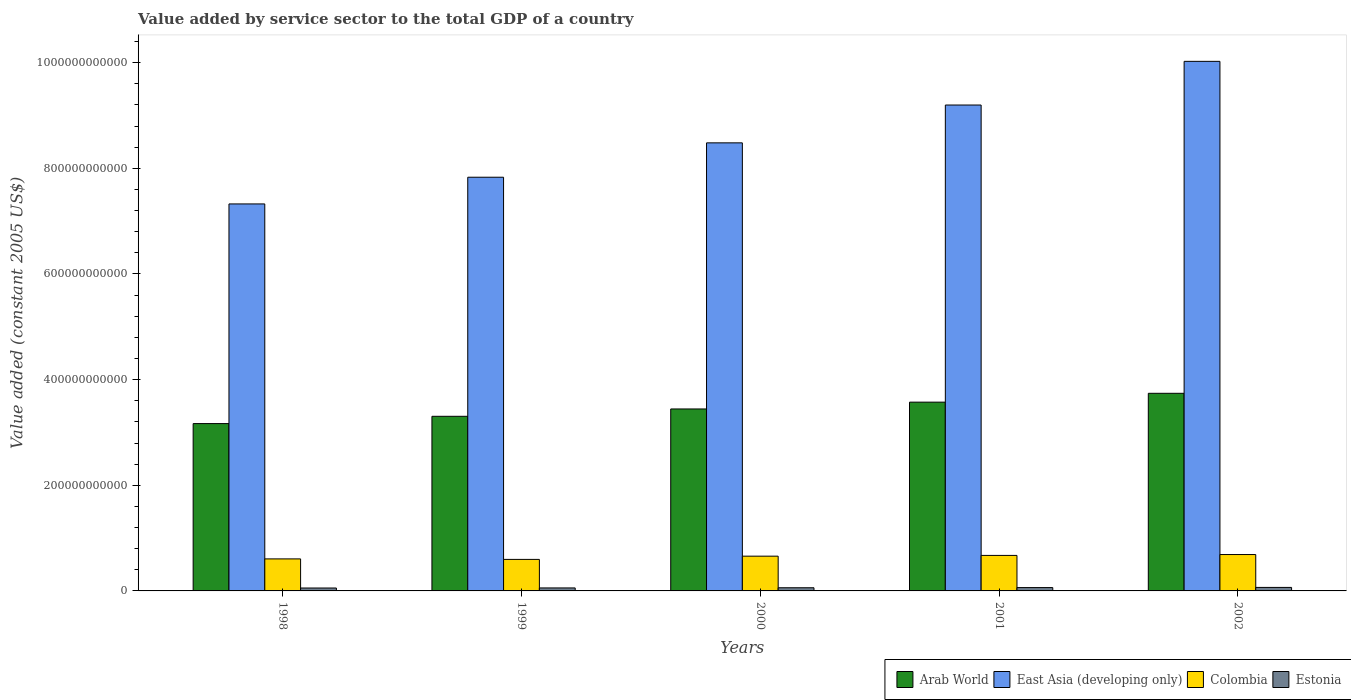Are the number of bars per tick equal to the number of legend labels?
Provide a short and direct response. Yes. Are the number of bars on each tick of the X-axis equal?
Keep it short and to the point. Yes. What is the label of the 4th group of bars from the left?
Offer a very short reply. 2001. In how many cases, is the number of bars for a given year not equal to the number of legend labels?
Your response must be concise. 0. What is the value added by service sector in Colombia in 2001?
Offer a terse response. 6.72e+1. Across all years, what is the maximum value added by service sector in Arab World?
Give a very brief answer. 3.74e+11. Across all years, what is the minimum value added by service sector in Colombia?
Your answer should be compact. 5.97e+1. What is the total value added by service sector in East Asia (developing only) in the graph?
Keep it short and to the point. 4.29e+12. What is the difference between the value added by service sector in Colombia in 1998 and that in 2000?
Offer a terse response. -5.19e+09. What is the difference between the value added by service sector in East Asia (developing only) in 2002 and the value added by service sector in Arab World in 1999?
Your answer should be very brief. 6.72e+11. What is the average value added by service sector in Arab World per year?
Your response must be concise. 3.45e+11. In the year 1998, what is the difference between the value added by service sector in East Asia (developing only) and value added by service sector in Colombia?
Your response must be concise. 6.72e+11. What is the ratio of the value added by service sector in Estonia in 1999 to that in 2002?
Ensure brevity in your answer.  0.85. Is the difference between the value added by service sector in East Asia (developing only) in 2000 and 2002 greater than the difference between the value added by service sector in Colombia in 2000 and 2002?
Your answer should be compact. No. What is the difference between the highest and the second highest value added by service sector in Colombia?
Give a very brief answer. 1.65e+09. What is the difference between the highest and the lowest value added by service sector in East Asia (developing only)?
Your response must be concise. 2.70e+11. In how many years, is the value added by service sector in East Asia (developing only) greater than the average value added by service sector in East Asia (developing only) taken over all years?
Provide a succinct answer. 2. Is the sum of the value added by service sector in East Asia (developing only) in 2001 and 2002 greater than the maximum value added by service sector in Estonia across all years?
Provide a succinct answer. Yes. What does the 4th bar from the left in 1998 represents?
Your answer should be very brief. Estonia. What does the 2nd bar from the right in 2001 represents?
Offer a very short reply. Colombia. How many bars are there?
Offer a terse response. 20. Are all the bars in the graph horizontal?
Ensure brevity in your answer.  No. What is the difference between two consecutive major ticks on the Y-axis?
Offer a terse response. 2.00e+11. Where does the legend appear in the graph?
Your answer should be compact. Bottom right. How are the legend labels stacked?
Your answer should be compact. Horizontal. What is the title of the graph?
Provide a short and direct response. Value added by service sector to the total GDP of a country. Does "Trinidad and Tobago" appear as one of the legend labels in the graph?
Your answer should be compact. No. What is the label or title of the Y-axis?
Your answer should be compact. Value added (constant 2005 US$). What is the Value added (constant 2005 US$) of Arab World in 1998?
Keep it short and to the point. 3.17e+11. What is the Value added (constant 2005 US$) in East Asia (developing only) in 1998?
Ensure brevity in your answer.  7.33e+11. What is the Value added (constant 2005 US$) in Colombia in 1998?
Keep it short and to the point. 6.06e+1. What is the Value added (constant 2005 US$) of Estonia in 1998?
Your response must be concise. 5.52e+09. What is the Value added (constant 2005 US$) in Arab World in 1999?
Give a very brief answer. 3.31e+11. What is the Value added (constant 2005 US$) of East Asia (developing only) in 1999?
Give a very brief answer. 7.83e+11. What is the Value added (constant 2005 US$) in Colombia in 1999?
Provide a short and direct response. 5.97e+1. What is the Value added (constant 2005 US$) of Estonia in 1999?
Offer a terse response. 5.65e+09. What is the Value added (constant 2005 US$) in Arab World in 2000?
Provide a short and direct response. 3.44e+11. What is the Value added (constant 2005 US$) in East Asia (developing only) in 2000?
Provide a short and direct response. 8.48e+11. What is the Value added (constant 2005 US$) in Colombia in 2000?
Provide a short and direct response. 6.58e+1. What is the Value added (constant 2005 US$) of Estonia in 2000?
Your response must be concise. 5.98e+09. What is the Value added (constant 2005 US$) in Arab World in 2001?
Provide a short and direct response. 3.57e+11. What is the Value added (constant 2005 US$) in East Asia (developing only) in 2001?
Offer a very short reply. 9.20e+11. What is the Value added (constant 2005 US$) of Colombia in 2001?
Make the answer very short. 6.72e+1. What is the Value added (constant 2005 US$) in Estonia in 2001?
Your answer should be very brief. 6.33e+09. What is the Value added (constant 2005 US$) of Arab World in 2002?
Provide a succinct answer. 3.74e+11. What is the Value added (constant 2005 US$) of East Asia (developing only) in 2002?
Give a very brief answer. 1.00e+12. What is the Value added (constant 2005 US$) of Colombia in 2002?
Offer a very short reply. 6.89e+1. What is the Value added (constant 2005 US$) of Estonia in 2002?
Your answer should be compact. 6.65e+09. Across all years, what is the maximum Value added (constant 2005 US$) of Arab World?
Offer a terse response. 3.74e+11. Across all years, what is the maximum Value added (constant 2005 US$) in East Asia (developing only)?
Make the answer very short. 1.00e+12. Across all years, what is the maximum Value added (constant 2005 US$) of Colombia?
Provide a succinct answer. 6.89e+1. Across all years, what is the maximum Value added (constant 2005 US$) of Estonia?
Provide a succinct answer. 6.65e+09. Across all years, what is the minimum Value added (constant 2005 US$) in Arab World?
Keep it short and to the point. 3.17e+11. Across all years, what is the minimum Value added (constant 2005 US$) in East Asia (developing only)?
Keep it short and to the point. 7.33e+11. Across all years, what is the minimum Value added (constant 2005 US$) in Colombia?
Ensure brevity in your answer.  5.97e+1. Across all years, what is the minimum Value added (constant 2005 US$) in Estonia?
Offer a very short reply. 5.52e+09. What is the total Value added (constant 2005 US$) of Arab World in the graph?
Provide a short and direct response. 1.72e+12. What is the total Value added (constant 2005 US$) of East Asia (developing only) in the graph?
Make the answer very short. 4.29e+12. What is the total Value added (constant 2005 US$) in Colombia in the graph?
Offer a very short reply. 3.22e+11. What is the total Value added (constant 2005 US$) of Estonia in the graph?
Keep it short and to the point. 3.01e+1. What is the difference between the Value added (constant 2005 US$) of Arab World in 1998 and that in 1999?
Your answer should be compact. -1.38e+1. What is the difference between the Value added (constant 2005 US$) of East Asia (developing only) in 1998 and that in 1999?
Provide a short and direct response. -5.06e+1. What is the difference between the Value added (constant 2005 US$) of Colombia in 1998 and that in 1999?
Offer a terse response. 9.21e+08. What is the difference between the Value added (constant 2005 US$) of Estonia in 1998 and that in 1999?
Offer a terse response. -1.28e+08. What is the difference between the Value added (constant 2005 US$) of Arab World in 1998 and that in 2000?
Make the answer very short. -2.77e+1. What is the difference between the Value added (constant 2005 US$) in East Asia (developing only) in 1998 and that in 2000?
Provide a succinct answer. -1.16e+11. What is the difference between the Value added (constant 2005 US$) in Colombia in 1998 and that in 2000?
Offer a terse response. -5.19e+09. What is the difference between the Value added (constant 2005 US$) in Estonia in 1998 and that in 2000?
Ensure brevity in your answer.  -4.53e+08. What is the difference between the Value added (constant 2005 US$) in Arab World in 1998 and that in 2001?
Provide a succinct answer. -4.06e+1. What is the difference between the Value added (constant 2005 US$) of East Asia (developing only) in 1998 and that in 2001?
Offer a very short reply. -1.87e+11. What is the difference between the Value added (constant 2005 US$) of Colombia in 1998 and that in 2001?
Your answer should be compact. -6.61e+09. What is the difference between the Value added (constant 2005 US$) in Estonia in 1998 and that in 2001?
Keep it short and to the point. -8.04e+08. What is the difference between the Value added (constant 2005 US$) in Arab World in 1998 and that in 2002?
Offer a terse response. -5.73e+1. What is the difference between the Value added (constant 2005 US$) in East Asia (developing only) in 1998 and that in 2002?
Your response must be concise. -2.70e+11. What is the difference between the Value added (constant 2005 US$) in Colombia in 1998 and that in 2002?
Ensure brevity in your answer.  -8.26e+09. What is the difference between the Value added (constant 2005 US$) in Estonia in 1998 and that in 2002?
Make the answer very short. -1.13e+09. What is the difference between the Value added (constant 2005 US$) of Arab World in 1999 and that in 2000?
Your answer should be compact. -1.39e+1. What is the difference between the Value added (constant 2005 US$) of East Asia (developing only) in 1999 and that in 2000?
Make the answer very short. -6.51e+1. What is the difference between the Value added (constant 2005 US$) in Colombia in 1999 and that in 2000?
Your response must be concise. -6.11e+09. What is the difference between the Value added (constant 2005 US$) in Estonia in 1999 and that in 2000?
Your answer should be compact. -3.25e+08. What is the difference between the Value added (constant 2005 US$) of Arab World in 1999 and that in 2001?
Provide a succinct answer. -2.68e+1. What is the difference between the Value added (constant 2005 US$) of East Asia (developing only) in 1999 and that in 2001?
Your answer should be very brief. -1.37e+11. What is the difference between the Value added (constant 2005 US$) in Colombia in 1999 and that in 2001?
Ensure brevity in your answer.  -7.53e+09. What is the difference between the Value added (constant 2005 US$) of Estonia in 1999 and that in 2001?
Give a very brief answer. -6.76e+08. What is the difference between the Value added (constant 2005 US$) in Arab World in 1999 and that in 2002?
Keep it short and to the point. -4.35e+1. What is the difference between the Value added (constant 2005 US$) in East Asia (developing only) in 1999 and that in 2002?
Provide a succinct answer. -2.19e+11. What is the difference between the Value added (constant 2005 US$) in Colombia in 1999 and that in 2002?
Give a very brief answer. -9.19e+09. What is the difference between the Value added (constant 2005 US$) in Estonia in 1999 and that in 2002?
Offer a terse response. -1.00e+09. What is the difference between the Value added (constant 2005 US$) of Arab World in 2000 and that in 2001?
Provide a succinct answer. -1.29e+1. What is the difference between the Value added (constant 2005 US$) in East Asia (developing only) in 2000 and that in 2001?
Provide a short and direct response. -7.16e+1. What is the difference between the Value added (constant 2005 US$) of Colombia in 2000 and that in 2001?
Your response must be concise. -1.42e+09. What is the difference between the Value added (constant 2005 US$) of Estonia in 2000 and that in 2001?
Give a very brief answer. -3.51e+08. What is the difference between the Value added (constant 2005 US$) of Arab World in 2000 and that in 2002?
Your answer should be very brief. -2.96e+1. What is the difference between the Value added (constant 2005 US$) in East Asia (developing only) in 2000 and that in 2002?
Keep it short and to the point. -1.54e+11. What is the difference between the Value added (constant 2005 US$) in Colombia in 2000 and that in 2002?
Your response must be concise. -3.07e+09. What is the difference between the Value added (constant 2005 US$) of Estonia in 2000 and that in 2002?
Keep it short and to the point. -6.76e+08. What is the difference between the Value added (constant 2005 US$) in Arab World in 2001 and that in 2002?
Ensure brevity in your answer.  -1.67e+1. What is the difference between the Value added (constant 2005 US$) in East Asia (developing only) in 2001 and that in 2002?
Your response must be concise. -8.27e+1. What is the difference between the Value added (constant 2005 US$) of Colombia in 2001 and that in 2002?
Make the answer very short. -1.65e+09. What is the difference between the Value added (constant 2005 US$) in Estonia in 2001 and that in 2002?
Your answer should be very brief. -3.25e+08. What is the difference between the Value added (constant 2005 US$) in Arab World in 1998 and the Value added (constant 2005 US$) in East Asia (developing only) in 1999?
Ensure brevity in your answer.  -4.66e+11. What is the difference between the Value added (constant 2005 US$) in Arab World in 1998 and the Value added (constant 2005 US$) in Colombia in 1999?
Offer a terse response. 2.57e+11. What is the difference between the Value added (constant 2005 US$) in Arab World in 1998 and the Value added (constant 2005 US$) in Estonia in 1999?
Your answer should be very brief. 3.11e+11. What is the difference between the Value added (constant 2005 US$) in East Asia (developing only) in 1998 and the Value added (constant 2005 US$) in Colombia in 1999?
Provide a succinct answer. 6.73e+11. What is the difference between the Value added (constant 2005 US$) of East Asia (developing only) in 1998 and the Value added (constant 2005 US$) of Estonia in 1999?
Your answer should be compact. 7.27e+11. What is the difference between the Value added (constant 2005 US$) in Colombia in 1998 and the Value added (constant 2005 US$) in Estonia in 1999?
Offer a very short reply. 5.50e+1. What is the difference between the Value added (constant 2005 US$) of Arab World in 1998 and the Value added (constant 2005 US$) of East Asia (developing only) in 2000?
Give a very brief answer. -5.31e+11. What is the difference between the Value added (constant 2005 US$) of Arab World in 1998 and the Value added (constant 2005 US$) of Colombia in 2000?
Ensure brevity in your answer.  2.51e+11. What is the difference between the Value added (constant 2005 US$) in Arab World in 1998 and the Value added (constant 2005 US$) in Estonia in 2000?
Your answer should be very brief. 3.11e+11. What is the difference between the Value added (constant 2005 US$) of East Asia (developing only) in 1998 and the Value added (constant 2005 US$) of Colombia in 2000?
Your answer should be very brief. 6.67e+11. What is the difference between the Value added (constant 2005 US$) of East Asia (developing only) in 1998 and the Value added (constant 2005 US$) of Estonia in 2000?
Offer a very short reply. 7.27e+11. What is the difference between the Value added (constant 2005 US$) of Colombia in 1998 and the Value added (constant 2005 US$) of Estonia in 2000?
Give a very brief answer. 5.46e+1. What is the difference between the Value added (constant 2005 US$) in Arab World in 1998 and the Value added (constant 2005 US$) in East Asia (developing only) in 2001?
Your answer should be very brief. -6.03e+11. What is the difference between the Value added (constant 2005 US$) of Arab World in 1998 and the Value added (constant 2005 US$) of Colombia in 2001?
Your response must be concise. 2.50e+11. What is the difference between the Value added (constant 2005 US$) of Arab World in 1998 and the Value added (constant 2005 US$) of Estonia in 2001?
Your answer should be compact. 3.10e+11. What is the difference between the Value added (constant 2005 US$) in East Asia (developing only) in 1998 and the Value added (constant 2005 US$) in Colombia in 2001?
Your response must be concise. 6.65e+11. What is the difference between the Value added (constant 2005 US$) of East Asia (developing only) in 1998 and the Value added (constant 2005 US$) of Estonia in 2001?
Make the answer very short. 7.26e+11. What is the difference between the Value added (constant 2005 US$) in Colombia in 1998 and the Value added (constant 2005 US$) in Estonia in 2001?
Your response must be concise. 5.43e+1. What is the difference between the Value added (constant 2005 US$) of Arab World in 1998 and the Value added (constant 2005 US$) of East Asia (developing only) in 2002?
Offer a very short reply. -6.86e+11. What is the difference between the Value added (constant 2005 US$) of Arab World in 1998 and the Value added (constant 2005 US$) of Colombia in 2002?
Offer a very short reply. 2.48e+11. What is the difference between the Value added (constant 2005 US$) of Arab World in 1998 and the Value added (constant 2005 US$) of Estonia in 2002?
Give a very brief answer. 3.10e+11. What is the difference between the Value added (constant 2005 US$) in East Asia (developing only) in 1998 and the Value added (constant 2005 US$) in Colombia in 2002?
Your answer should be very brief. 6.64e+11. What is the difference between the Value added (constant 2005 US$) in East Asia (developing only) in 1998 and the Value added (constant 2005 US$) in Estonia in 2002?
Offer a very short reply. 7.26e+11. What is the difference between the Value added (constant 2005 US$) in Colombia in 1998 and the Value added (constant 2005 US$) in Estonia in 2002?
Give a very brief answer. 5.40e+1. What is the difference between the Value added (constant 2005 US$) in Arab World in 1999 and the Value added (constant 2005 US$) in East Asia (developing only) in 2000?
Ensure brevity in your answer.  -5.18e+11. What is the difference between the Value added (constant 2005 US$) in Arab World in 1999 and the Value added (constant 2005 US$) in Colombia in 2000?
Provide a succinct answer. 2.65e+11. What is the difference between the Value added (constant 2005 US$) of Arab World in 1999 and the Value added (constant 2005 US$) of Estonia in 2000?
Ensure brevity in your answer.  3.25e+11. What is the difference between the Value added (constant 2005 US$) of East Asia (developing only) in 1999 and the Value added (constant 2005 US$) of Colombia in 2000?
Your response must be concise. 7.17e+11. What is the difference between the Value added (constant 2005 US$) of East Asia (developing only) in 1999 and the Value added (constant 2005 US$) of Estonia in 2000?
Provide a succinct answer. 7.77e+11. What is the difference between the Value added (constant 2005 US$) in Colombia in 1999 and the Value added (constant 2005 US$) in Estonia in 2000?
Provide a short and direct response. 5.37e+1. What is the difference between the Value added (constant 2005 US$) of Arab World in 1999 and the Value added (constant 2005 US$) of East Asia (developing only) in 2001?
Ensure brevity in your answer.  -5.89e+11. What is the difference between the Value added (constant 2005 US$) in Arab World in 1999 and the Value added (constant 2005 US$) in Colombia in 2001?
Keep it short and to the point. 2.63e+11. What is the difference between the Value added (constant 2005 US$) of Arab World in 1999 and the Value added (constant 2005 US$) of Estonia in 2001?
Your answer should be compact. 3.24e+11. What is the difference between the Value added (constant 2005 US$) in East Asia (developing only) in 1999 and the Value added (constant 2005 US$) in Colombia in 2001?
Offer a very short reply. 7.16e+11. What is the difference between the Value added (constant 2005 US$) of East Asia (developing only) in 1999 and the Value added (constant 2005 US$) of Estonia in 2001?
Keep it short and to the point. 7.77e+11. What is the difference between the Value added (constant 2005 US$) in Colombia in 1999 and the Value added (constant 2005 US$) in Estonia in 2001?
Provide a short and direct response. 5.34e+1. What is the difference between the Value added (constant 2005 US$) in Arab World in 1999 and the Value added (constant 2005 US$) in East Asia (developing only) in 2002?
Make the answer very short. -6.72e+11. What is the difference between the Value added (constant 2005 US$) in Arab World in 1999 and the Value added (constant 2005 US$) in Colombia in 2002?
Your response must be concise. 2.62e+11. What is the difference between the Value added (constant 2005 US$) of Arab World in 1999 and the Value added (constant 2005 US$) of Estonia in 2002?
Give a very brief answer. 3.24e+11. What is the difference between the Value added (constant 2005 US$) of East Asia (developing only) in 1999 and the Value added (constant 2005 US$) of Colombia in 2002?
Provide a succinct answer. 7.14e+11. What is the difference between the Value added (constant 2005 US$) in East Asia (developing only) in 1999 and the Value added (constant 2005 US$) in Estonia in 2002?
Ensure brevity in your answer.  7.76e+11. What is the difference between the Value added (constant 2005 US$) of Colombia in 1999 and the Value added (constant 2005 US$) of Estonia in 2002?
Offer a terse response. 5.30e+1. What is the difference between the Value added (constant 2005 US$) of Arab World in 2000 and the Value added (constant 2005 US$) of East Asia (developing only) in 2001?
Offer a very short reply. -5.75e+11. What is the difference between the Value added (constant 2005 US$) in Arab World in 2000 and the Value added (constant 2005 US$) in Colombia in 2001?
Ensure brevity in your answer.  2.77e+11. What is the difference between the Value added (constant 2005 US$) in Arab World in 2000 and the Value added (constant 2005 US$) in Estonia in 2001?
Make the answer very short. 3.38e+11. What is the difference between the Value added (constant 2005 US$) of East Asia (developing only) in 2000 and the Value added (constant 2005 US$) of Colombia in 2001?
Provide a short and direct response. 7.81e+11. What is the difference between the Value added (constant 2005 US$) in East Asia (developing only) in 2000 and the Value added (constant 2005 US$) in Estonia in 2001?
Your answer should be compact. 8.42e+11. What is the difference between the Value added (constant 2005 US$) of Colombia in 2000 and the Value added (constant 2005 US$) of Estonia in 2001?
Provide a succinct answer. 5.95e+1. What is the difference between the Value added (constant 2005 US$) in Arab World in 2000 and the Value added (constant 2005 US$) in East Asia (developing only) in 2002?
Your response must be concise. -6.58e+11. What is the difference between the Value added (constant 2005 US$) in Arab World in 2000 and the Value added (constant 2005 US$) in Colombia in 2002?
Offer a very short reply. 2.76e+11. What is the difference between the Value added (constant 2005 US$) in Arab World in 2000 and the Value added (constant 2005 US$) in Estonia in 2002?
Your answer should be compact. 3.38e+11. What is the difference between the Value added (constant 2005 US$) of East Asia (developing only) in 2000 and the Value added (constant 2005 US$) of Colombia in 2002?
Your response must be concise. 7.79e+11. What is the difference between the Value added (constant 2005 US$) of East Asia (developing only) in 2000 and the Value added (constant 2005 US$) of Estonia in 2002?
Your answer should be compact. 8.42e+11. What is the difference between the Value added (constant 2005 US$) of Colombia in 2000 and the Value added (constant 2005 US$) of Estonia in 2002?
Ensure brevity in your answer.  5.91e+1. What is the difference between the Value added (constant 2005 US$) of Arab World in 2001 and the Value added (constant 2005 US$) of East Asia (developing only) in 2002?
Make the answer very short. -6.45e+11. What is the difference between the Value added (constant 2005 US$) of Arab World in 2001 and the Value added (constant 2005 US$) of Colombia in 2002?
Your response must be concise. 2.88e+11. What is the difference between the Value added (constant 2005 US$) in Arab World in 2001 and the Value added (constant 2005 US$) in Estonia in 2002?
Ensure brevity in your answer.  3.51e+11. What is the difference between the Value added (constant 2005 US$) in East Asia (developing only) in 2001 and the Value added (constant 2005 US$) in Colombia in 2002?
Give a very brief answer. 8.51e+11. What is the difference between the Value added (constant 2005 US$) in East Asia (developing only) in 2001 and the Value added (constant 2005 US$) in Estonia in 2002?
Your response must be concise. 9.13e+11. What is the difference between the Value added (constant 2005 US$) of Colombia in 2001 and the Value added (constant 2005 US$) of Estonia in 2002?
Make the answer very short. 6.06e+1. What is the average Value added (constant 2005 US$) of Arab World per year?
Give a very brief answer. 3.45e+11. What is the average Value added (constant 2005 US$) in East Asia (developing only) per year?
Your answer should be very brief. 8.57e+11. What is the average Value added (constant 2005 US$) in Colombia per year?
Keep it short and to the point. 6.44e+1. What is the average Value added (constant 2005 US$) of Estonia per year?
Ensure brevity in your answer.  6.03e+09. In the year 1998, what is the difference between the Value added (constant 2005 US$) in Arab World and Value added (constant 2005 US$) in East Asia (developing only)?
Provide a short and direct response. -4.16e+11. In the year 1998, what is the difference between the Value added (constant 2005 US$) of Arab World and Value added (constant 2005 US$) of Colombia?
Give a very brief answer. 2.56e+11. In the year 1998, what is the difference between the Value added (constant 2005 US$) of Arab World and Value added (constant 2005 US$) of Estonia?
Provide a succinct answer. 3.11e+11. In the year 1998, what is the difference between the Value added (constant 2005 US$) in East Asia (developing only) and Value added (constant 2005 US$) in Colombia?
Your response must be concise. 6.72e+11. In the year 1998, what is the difference between the Value added (constant 2005 US$) in East Asia (developing only) and Value added (constant 2005 US$) in Estonia?
Give a very brief answer. 7.27e+11. In the year 1998, what is the difference between the Value added (constant 2005 US$) of Colombia and Value added (constant 2005 US$) of Estonia?
Provide a short and direct response. 5.51e+1. In the year 1999, what is the difference between the Value added (constant 2005 US$) of Arab World and Value added (constant 2005 US$) of East Asia (developing only)?
Offer a very short reply. -4.53e+11. In the year 1999, what is the difference between the Value added (constant 2005 US$) in Arab World and Value added (constant 2005 US$) in Colombia?
Provide a succinct answer. 2.71e+11. In the year 1999, what is the difference between the Value added (constant 2005 US$) of Arab World and Value added (constant 2005 US$) of Estonia?
Offer a terse response. 3.25e+11. In the year 1999, what is the difference between the Value added (constant 2005 US$) of East Asia (developing only) and Value added (constant 2005 US$) of Colombia?
Offer a very short reply. 7.23e+11. In the year 1999, what is the difference between the Value added (constant 2005 US$) in East Asia (developing only) and Value added (constant 2005 US$) in Estonia?
Your answer should be compact. 7.77e+11. In the year 1999, what is the difference between the Value added (constant 2005 US$) in Colombia and Value added (constant 2005 US$) in Estonia?
Your answer should be very brief. 5.40e+1. In the year 2000, what is the difference between the Value added (constant 2005 US$) of Arab World and Value added (constant 2005 US$) of East Asia (developing only)?
Offer a terse response. -5.04e+11. In the year 2000, what is the difference between the Value added (constant 2005 US$) of Arab World and Value added (constant 2005 US$) of Colombia?
Your response must be concise. 2.79e+11. In the year 2000, what is the difference between the Value added (constant 2005 US$) of Arab World and Value added (constant 2005 US$) of Estonia?
Ensure brevity in your answer.  3.38e+11. In the year 2000, what is the difference between the Value added (constant 2005 US$) of East Asia (developing only) and Value added (constant 2005 US$) of Colombia?
Offer a very short reply. 7.82e+11. In the year 2000, what is the difference between the Value added (constant 2005 US$) in East Asia (developing only) and Value added (constant 2005 US$) in Estonia?
Give a very brief answer. 8.42e+11. In the year 2000, what is the difference between the Value added (constant 2005 US$) in Colombia and Value added (constant 2005 US$) in Estonia?
Ensure brevity in your answer.  5.98e+1. In the year 2001, what is the difference between the Value added (constant 2005 US$) in Arab World and Value added (constant 2005 US$) in East Asia (developing only)?
Provide a short and direct response. -5.62e+11. In the year 2001, what is the difference between the Value added (constant 2005 US$) of Arab World and Value added (constant 2005 US$) of Colombia?
Offer a terse response. 2.90e+11. In the year 2001, what is the difference between the Value added (constant 2005 US$) in Arab World and Value added (constant 2005 US$) in Estonia?
Your answer should be very brief. 3.51e+11. In the year 2001, what is the difference between the Value added (constant 2005 US$) in East Asia (developing only) and Value added (constant 2005 US$) in Colombia?
Give a very brief answer. 8.53e+11. In the year 2001, what is the difference between the Value added (constant 2005 US$) in East Asia (developing only) and Value added (constant 2005 US$) in Estonia?
Provide a succinct answer. 9.13e+11. In the year 2001, what is the difference between the Value added (constant 2005 US$) of Colombia and Value added (constant 2005 US$) of Estonia?
Make the answer very short. 6.09e+1. In the year 2002, what is the difference between the Value added (constant 2005 US$) in Arab World and Value added (constant 2005 US$) in East Asia (developing only)?
Provide a succinct answer. -6.28e+11. In the year 2002, what is the difference between the Value added (constant 2005 US$) in Arab World and Value added (constant 2005 US$) in Colombia?
Offer a terse response. 3.05e+11. In the year 2002, what is the difference between the Value added (constant 2005 US$) in Arab World and Value added (constant 2005 US$) in Estonia?
Offer a very short reply. 3.67e+11. In the year 2002, what is the difference between the Value added (constant 2005 US$) in East Asia (developing only) and Value added (constant 2005 US$) in Colombia?
Give a very brief answer. 9.34e+11. In the year 2002, what is the difference between the Value added (constant 2005 US$) in East Asia (developing only) and Value added (constant 2005 US$) in Estonia?
Your answer should be compact. 9.96e+11. In the year 2002, what is the difference between the Value added (constant 2005 US$) of Colombia and Value added (constant 2005 US$) of Estonia?
Give a very brief answer. 6.22e+1. What is the ratio of the Value added (constant 2005 US$) in Arab World in 1998 to that in 1999?
Your response must be concise. 0.96. What is the ratio of the Value added (constant 2005 US$) of East Asia (developing only) in 1998 to that in 1999?
Keep it short and to the point. 0.94. What is the ratio of the Value added (constant 2005 US$) in Colombia in 1998 to that in 1999?
Offer a terse response. 1.02. What is the ratio of the Value added (constant 2005 US$) of Estonia in 1998 to that in 1999?
Your answer should be compact. 0.98. What is the ratio of the Value added (constant 2005 US$) of Arab World in 1998 to that in 2000?
Provide a succinct answer. 0.92. What is the ratio of the Value added (constant 2005 US$) in East Asia (developing only) in 1998 to that in 2000?
Ensure brevity in your answer.  0.86. What is the ratio of the Value added (constant 2005 US$) in Colombia in 1998 to that in 2000?
Offer a very short reply. 0.92. What is the ratio of the Value added (constant 2005 US$) in Estonia in 1998 to that in 2000?
Provide a short and direct response. 0.92. What is the ratio of the Value added (constant 2005 US$) in Arab World in 1998 to that in 2001?
Offer a very short reply. 0.89. What is the ratio of the Value added (constant 2005 US$) of East Asia (developing only) in 1998 to that in 2001?
Your answer should be compact. 0.8. What is the ratio of the Value added (constant 2005 US$) in Colombia in 1998 to that in 2001?
Offer a very short reply. 0.9. What is the ratio of the Value added (constant 2005 US$) in Estonia in 1998 to that in 2001?
Provide a succinct answer. 0.87. What is the ratio of the Value added (constant 2005 US$) in Arab World in 1998 to that in 2002?
Keep it short and to the point. 0.85. What is the ratio of the Value added (constant 2005 US$) in East Asia (developing only) in 1998 to that in 2002?
Your response must be concise. 0.73. What is the ratio of the Value added (constant 2005 US$) in Estonia in 1998 to that in 2002?
Offer a very short reply. 0.83. What is the ratio of the Value added (constant 2005 US$) in Arab World in 1999 to that in 2000?
Ensure brevity in your answer.  0.96. What is the ratio of the Value added (constant 2005 US$) in East Asia (developing only) in 1999 to that in 2000?
Your response must be concise. 0.92. What is the ratio of the Value added (constant 2005 US$) in Colombia in 1999 to that in 2000?
Make the answer very short. 0.91. What is the ratio of the Value added (constant 2005 US$) in Estonia in 1999 to that in 2000?
Ensure brevity in your answer.  0.95. What is the ratio of the Value added (constant 2005 US$) in Arab World in 1999 to that in 2001?
Make the answer very short. 0.93. What is the ratio of the Value added (constant 2005 US$) of East Asia (developing only) in 1999 to that in 2001?
Offer a very short reply. 0.85. What is the ratio of the Value added (constant 2005 US$) of Colombia in 1999 to that in 2001?
Your response must be concise. 0.89. What is the ratio of the Value added (constant 2005 US$) in Estonia in 1999 to that in 2001?
Provide a succinct answer. 0.89. What is the ratio of the Value added (constant 2005 US$) in Arab World in 1999 to that in 2002?
Ensure brevity in your answer.  0.88. What is the ratio of the Value added (constant 2005 US$) of East Asia (developing only) in 1999 to that in 2002?
Keep it short and to the point. 0.78. What is the ratio of the Value added (constant 2005 US$) in Colombia in 1999 to that in 2002?
Provide a short and direct response. 0.87. What is the ratio of the Value added (constant 2005 US$) in Estonia in 1999 to that in 2002?
Ensure brevity in your answer.  0.85. What is the ratio of the Value added (constant 2005 US$) of Arab World in 2000 to that in 2001?
Make the answer very short. 0.96. What is the ratio of the Value added (constant 2005 US$) of East Asia (developing only) in 2000 to that in 2001?
Ensure brevity in your answer.  0.92. What is the ratio of the Value added (constant 2005 US$) of Colombia in 2000 to that in 2001?
Your response must be concise. 0.98. What is the ratio of the Value added (constant 2005 US$) of Estonia in 2000 to that in 2001?
Your response must be concise. 0.94. What is the ratio of the Value added (constant 2005 US$) of Arab World in 2000 to that in 2002?
Provide a succinct answer. 0.92. What is the ratio of the Value added (constant 2005 US$) in East Asia (developing only) in 2000 to that in 2002?
Your answer should be very brief. 0.85. What is the ratio of the Value added (constant 2005 US$) in Colombia in 2000 to that in 2002?
Keep it short and to the point. 0.96. What is the ratio of the Value added (constant 2005 US$) of Estonia in 2000 to that in 2002?
Make the answer very short. 0.9. What is the ratio of the Value added (constant 2005 US$) of Arab World in 2001 to that in 2002?
Give a very brief answer. 0.96. What is the ratio of the Value added (constant 2005 US$) in East Asia (developing only) in 2001 to that in 2002?
Your answer should be very brief. 0.92. What is the ratio of the Value added (constant 2005 US$) in Colombia in 2001 to that in 2002?
Make the answer very short. 0.98. What is the ratio of the Value added (constant 2005 US$) in Estonia in 2001 to that in 2002?
Keep it short and to the point. 0.95. What is the difference between the highest and the second highest Value added (constant 2005 US$) of Arab World?
Provide a succinct answer. 1.67e+1. What is the difference between the highest and the second highest Value added (constant 2005 US$) of East Asia (developing only)?
Offer a very short reply. 8.27e+1. What is the difference between the highest and the second highest Value added (constant 2005 US$) of Colombia?
Ensure brevity in your answer.  1.65e+09. What is the difference between the highest and the second highest Value added (constant 2005 US$) in Estonia?
Keep it short and to the point. 3.25e+08. What is the difference between the highest and the lowest Value added (constant 2005 US$) in Arab World?
Offer a very short reply. 5.73e+1. What is the difference between the highest and the lowest Value added (constant 2005 US$) in East Asia (developing only)?
Keep it short and to the point. 2.70e+11. What is the difference between the highest and the lowest Value added (constant 2005 US$) in Colombia?
Give a very brief answer. 9.19e+09. What is the difference between the highest and the lowest Value added (constant 2005 US$) of Estonia?
Offer a very short reply. 1.13e+09. 